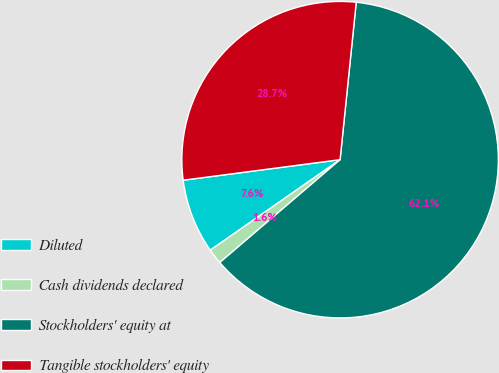Convert chart. <chart><loc_0><loc_0><loc_500><loc_500><pie_chart><fcel>Diluted<fcel>Cash dividends declared<fcel>Stockholders' equity at<fcel>Tangible stockholders' equity<nl><fcel>7.62%<fcel>1.57%<fcel>62.12%<fcel>28.7%<nl></chart> 